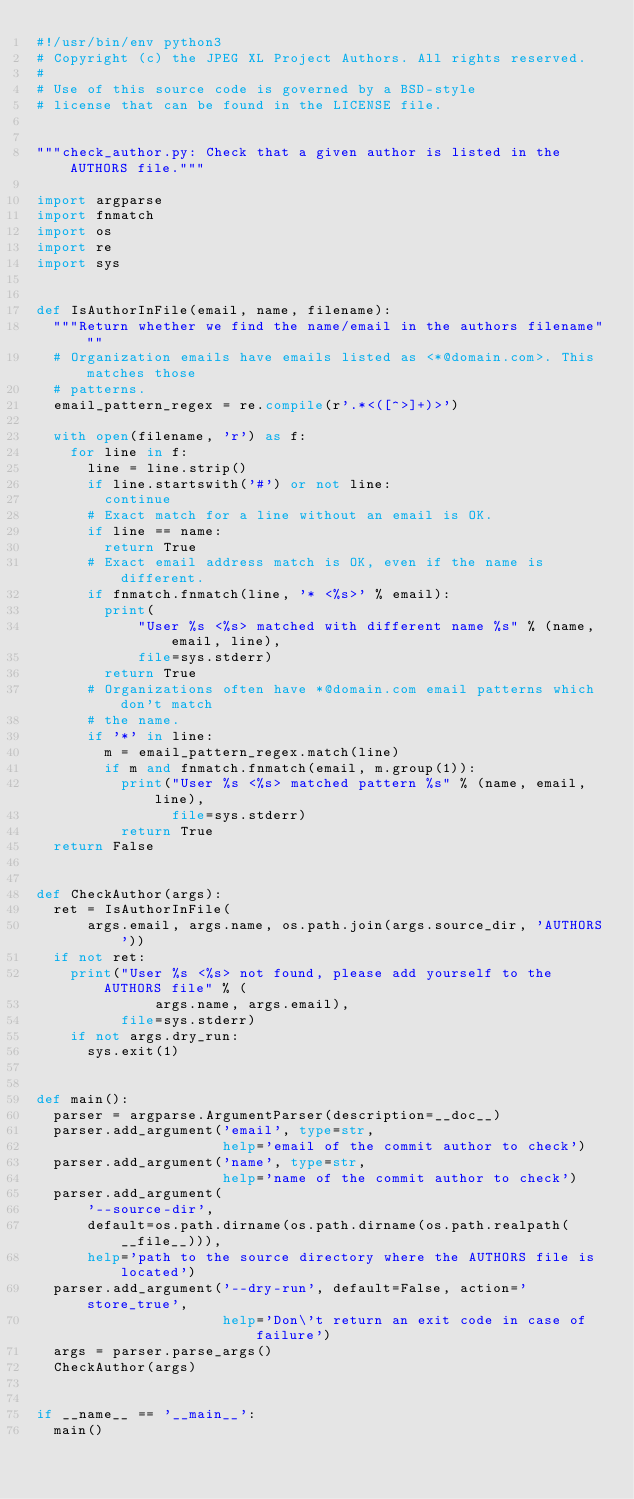Convert code to text. <code><loc_0><loc_0><loc_500><loc_500><_Python_>#!/usr/bin/env python3
# Copyright (c) the JPEG XL Project Authors. All rights reserved.
#
# Use of this source code is governed by a BSD-style
# license that can be found in the LICENSE file.


"""check_author.py: Check that a given author is listed in the AUTHORS file."""

import argparse
import fnmatch
import os
import re
import sys


def IsAuthorInFile(email, name, filename):
  """Return whether we find the name/email in the authors filename"""
  # Organization emails have emails listed as <*@domain.com>. This matches those
  # patterns.
  email_pattern_regex = re.compile(r'.*<([^>]+)>')

  with open(filename, 'r') as f:
    for line in f:
      line = line.strip()
      if line.startswith('#') or not line:
        continue
      # Exact match for a line without an email is OK.
      if line == name:
        return True
      # Exact email address match is OK, even if the name is different.
      if fnmatch.fnmatch(line, '* <%s>' % email):
        print(
            "User %s <%s> matched with different name %s" % (name, email, line),
            file=sys.stderr)
        return True
      # Organizations often have *@domain.com email patterns which don't match
      # the name.
      if '*' in line:
        m = email_pattern_regex.match(line)
        if m and fnmatch.fnmatch(email, m.group(1)):
          print("User %s <%s> matched pattern %s" % (name, email, line),
                file=sys.stderr)
          return True
  return False


def CheckAuthor(args):
  ret = IsAuthorInFile(
      args.email, args.name, os.path.join(args.source_dir, 'AUTHORS'))
  if not ret:
    print("User %s <%s> not found, please add yourself to the AUTHORS file" % (
              args.name, args.email),
          file=sys.stderr)
    if not args.dry_run:
      sys.exit(1)


def main():
  parser = argparse.ArgumentParser(description=__doc__)
  parser.add_argument('email', type=str,
                      help='email of the commit author to check')
  parser.add_argument('name', type=str,
                      help='name of the commit author to check')
  parser.add_argument(
      '--source-dir',
      default=os.path.dirname(os.path.dirname(os.path.realpath(__file__))),
      help='path to the source directory where the AUTHORS file is located')
  parser.add_argument('--dry-run', default=False, action='store_true',
                      help='Don\'t return an exit code in case of failure')
  args = parser.parse_args()
  CheckAuthor(args)


if __name__ == '__main__':
  main()
</code> 